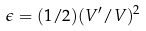<formula> <loc_0><loc_0><loc_500><loc_500>\epsilon = ( 1 / 2 ) ( V ^ { \prime } / V ) ^ { 2 }</formula> 